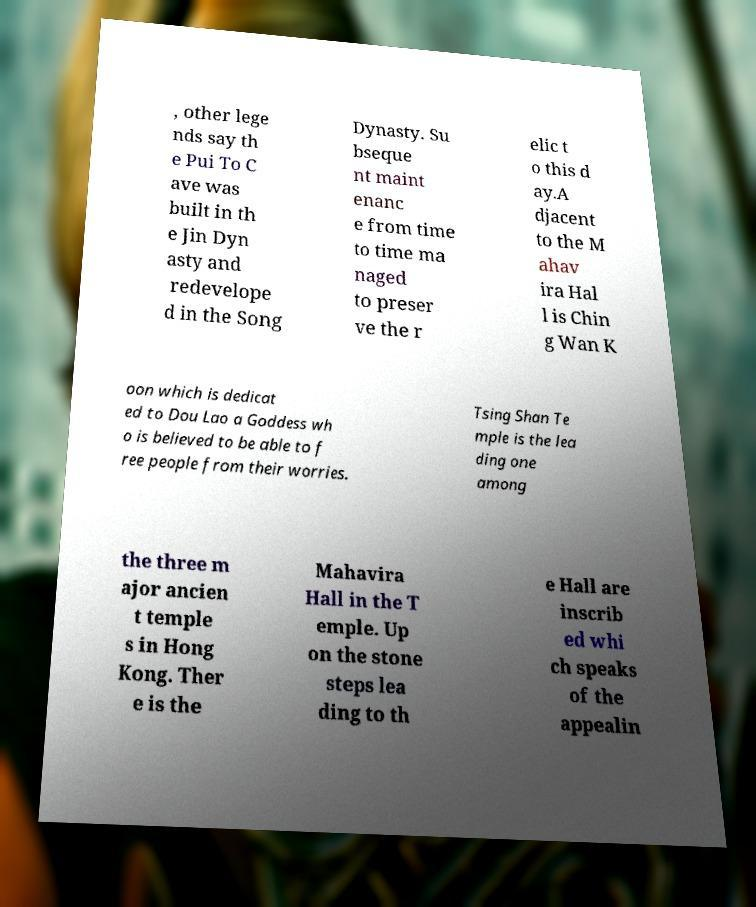What messages or text are displayed in this image? I need them in a readable, typed format. , other lege nds say th e Pui To C ave was built in th e Jin Dyn asty and redevelope d in the Song Dynasty. Su bseque nt maint enanc e from time to time ma naged to preser ve the r elic t o this d ay.A djacent to the M ahav ira Hal l is Chin g Wan K oon which is dedicat ed to Dou Lao a Goddess wh o is believed to be able to f ree people from their worries. Tsing Shan Te mple is the lea ding one among the three m ajor ancien t temple s in Hong Kong. Ther e is the Mahavira Hall in the T emple. Up on the stone steps lea ding to th e Hall are inscrib ed whi ch speaks of the appealin 